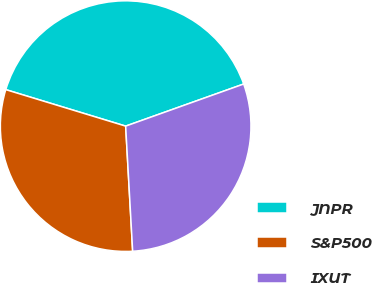Convert chart to OTSL. <chart><loc_0><loc_0><loc_500><loc_500><pie_chart><fcel>JNPR<fcel>S&P500<fcel>IXUT<nl><fcel>39.84%<fcel>30.59%<fcel>29.56%<nl></chart> 